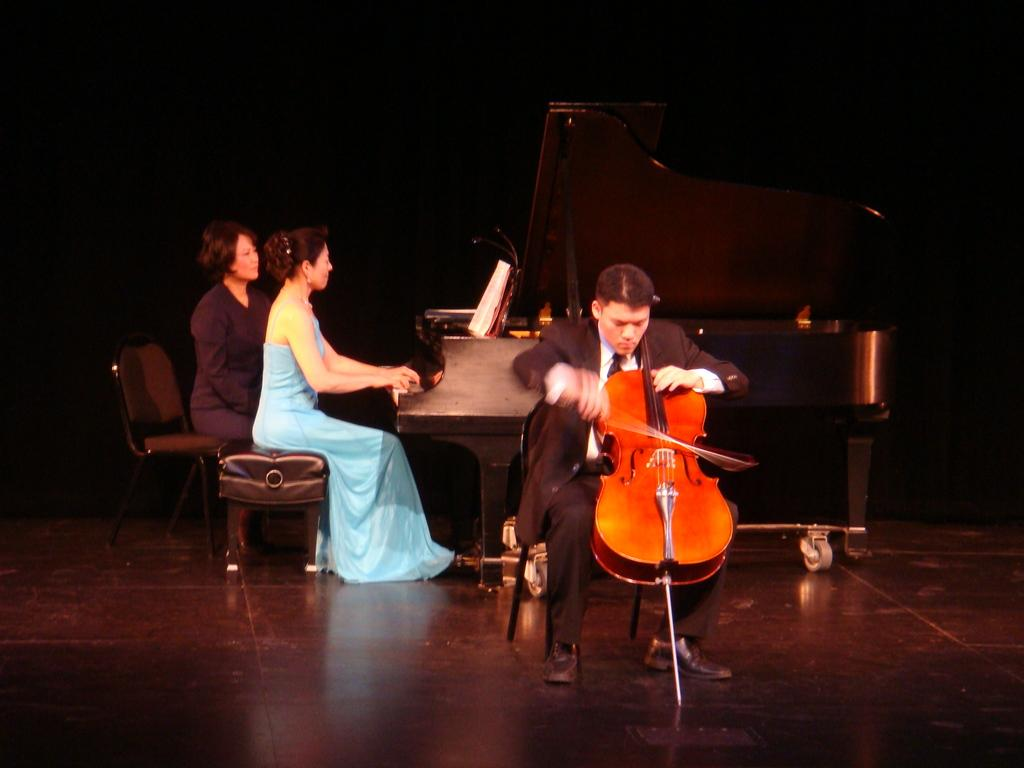What is the woman in the image doing? The woman is seated and playing the piano in the image. What is the man in the image doing? The man is playing the violin in the image. Are there any other people in the image besides the woman and the man? Yes, there is a woman seated on a chair on the side in the image. What type of government is depicted in the image? There is no depiction of a government in the image; it features people playing musical instruments. Can you tell me how many geese are present in the image? There are no geese present in the image; it features people playing musical instruments. 